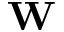Convert formula to latex. <formula><loc_0><loc_0><loc_500><loc_500>W</formula> 